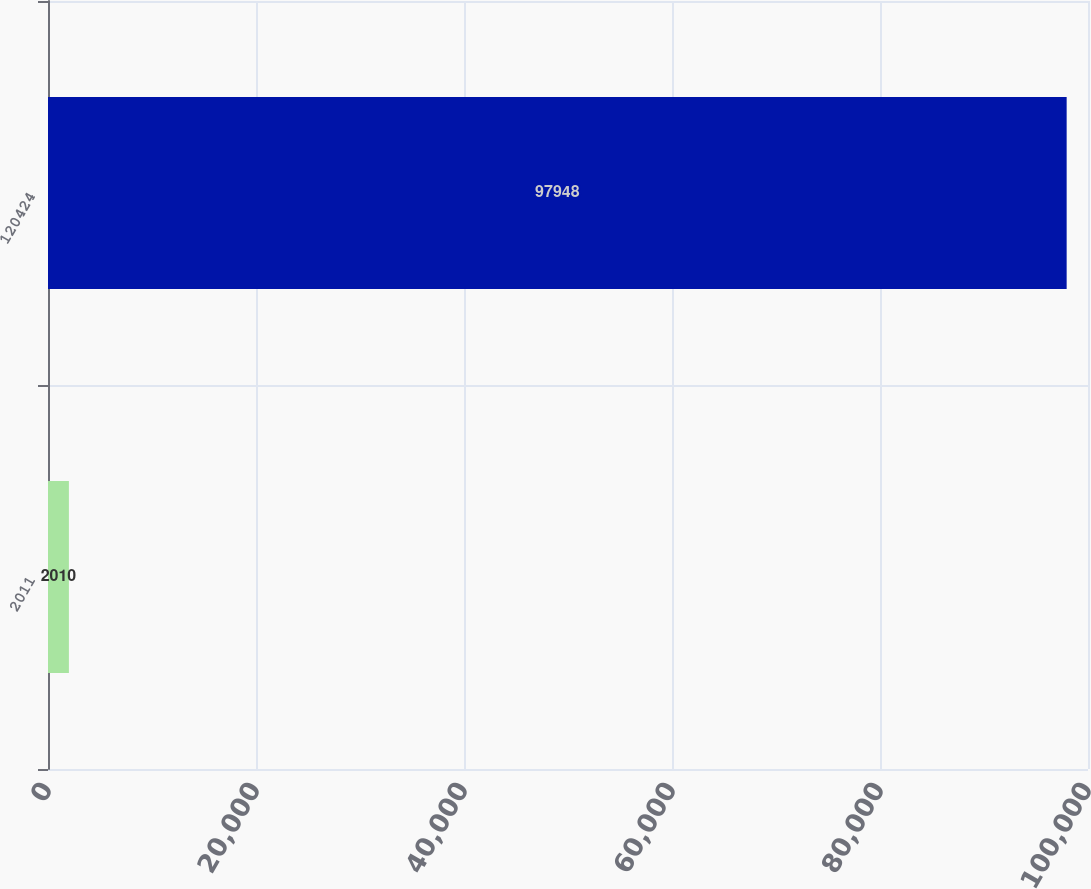<chart> <loc_0><loc_0><loc_500><loc_500><bar_chart><fcel>2011<fcel>120424<nl><fcel>2010<fcel>97948<nl></chart> 